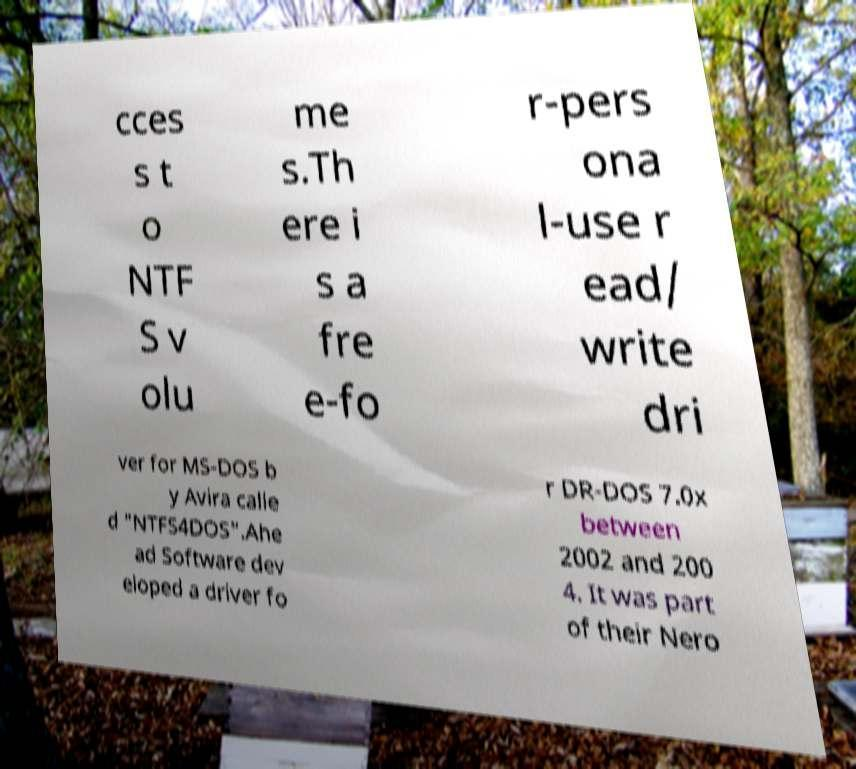Please read and relay the text visible in this image. What does it say? cces s t o NTF S v olu me s.Th ere i s a fre e-fo r-pers ona l-use r ead/ write dri ver for MS-DOS b y Avira calle d "NTFS4DOS".Ahe ad Software dev eloped a driver fo r DR-DOS 7.0x between 2002 and 200 4. It was part of their Nero 